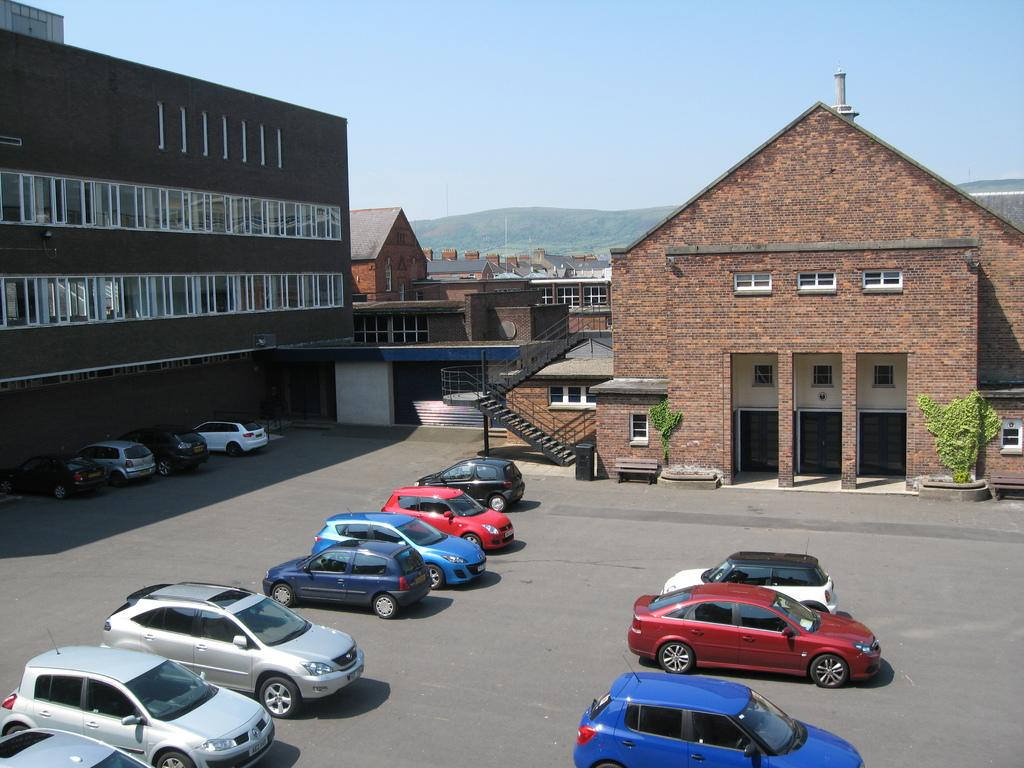What is located in front of the building in the image? There are cars parked in front of the building. What can be seen in the background of the image? There are buildings and mountains visible in the background of the image. Can you tell me how many donkeys are grazing in front of the building? There are no donkeys present in the image; it features cars parked in front of a building. What type of tax is being collected from the cars in the image? There is no indication of any tax being collected in the image; it simply shows cars parked in front of a building. 